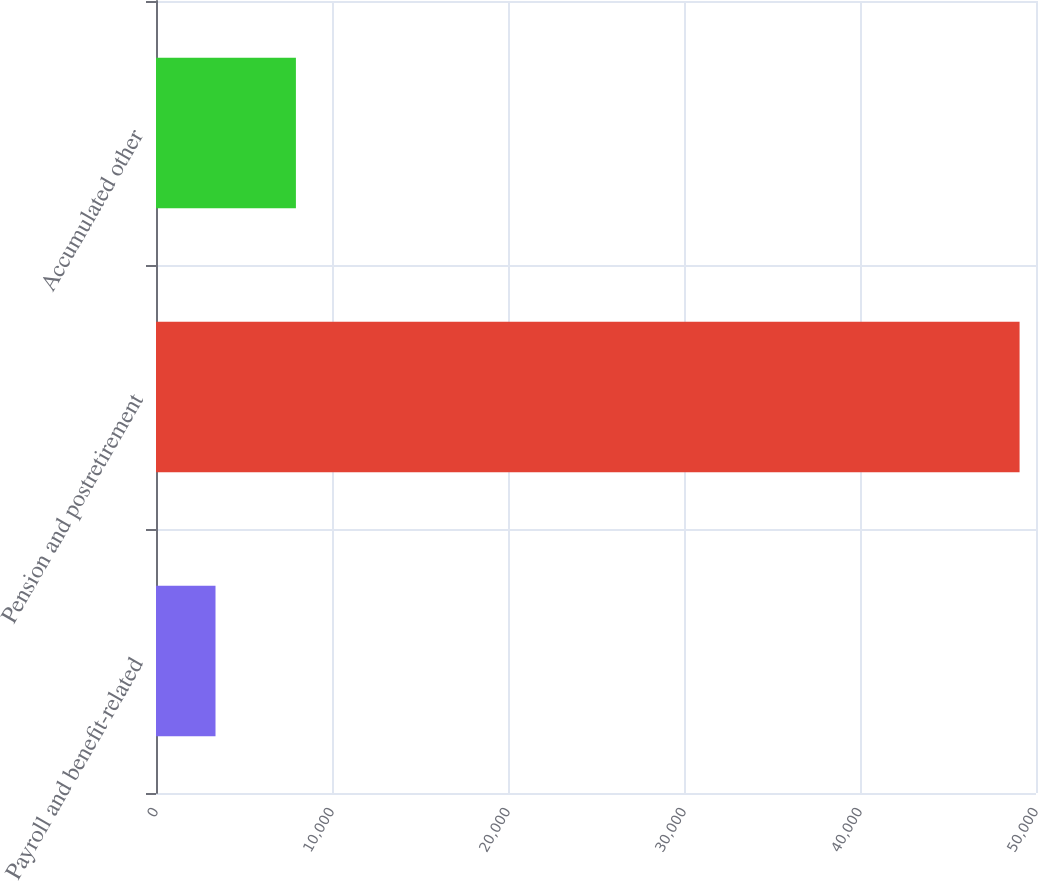<chart> <loc_0><loc_0><loc_500><loc_500><bar_chart><fcel>Payroll and benefit-related<fcel>Pension and postretirement<fcel>Accumulated other<nl><fcel>3381<fcel>49067<fcel>7949.6<nl></chart> 